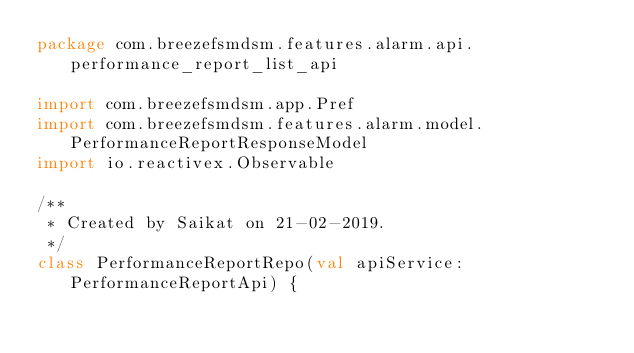Convert code to text. <code><loc_0><loc_0><loc_500><loc_500><_Kotlin_>package com.breezefsmdsm.features.alarm.api.performance_report_list_api

import com.breezefsmdsm.app.Pref
import com.breezefsmdsm.features.alarm.model.PerformanceReportResponseModel
import io.reactivex.Observable

/**
 * Created by Saikat on 21-02-2019.
 */
class PerformanceReportRepo(val apiService: PerformanceReportApi) {</code> 